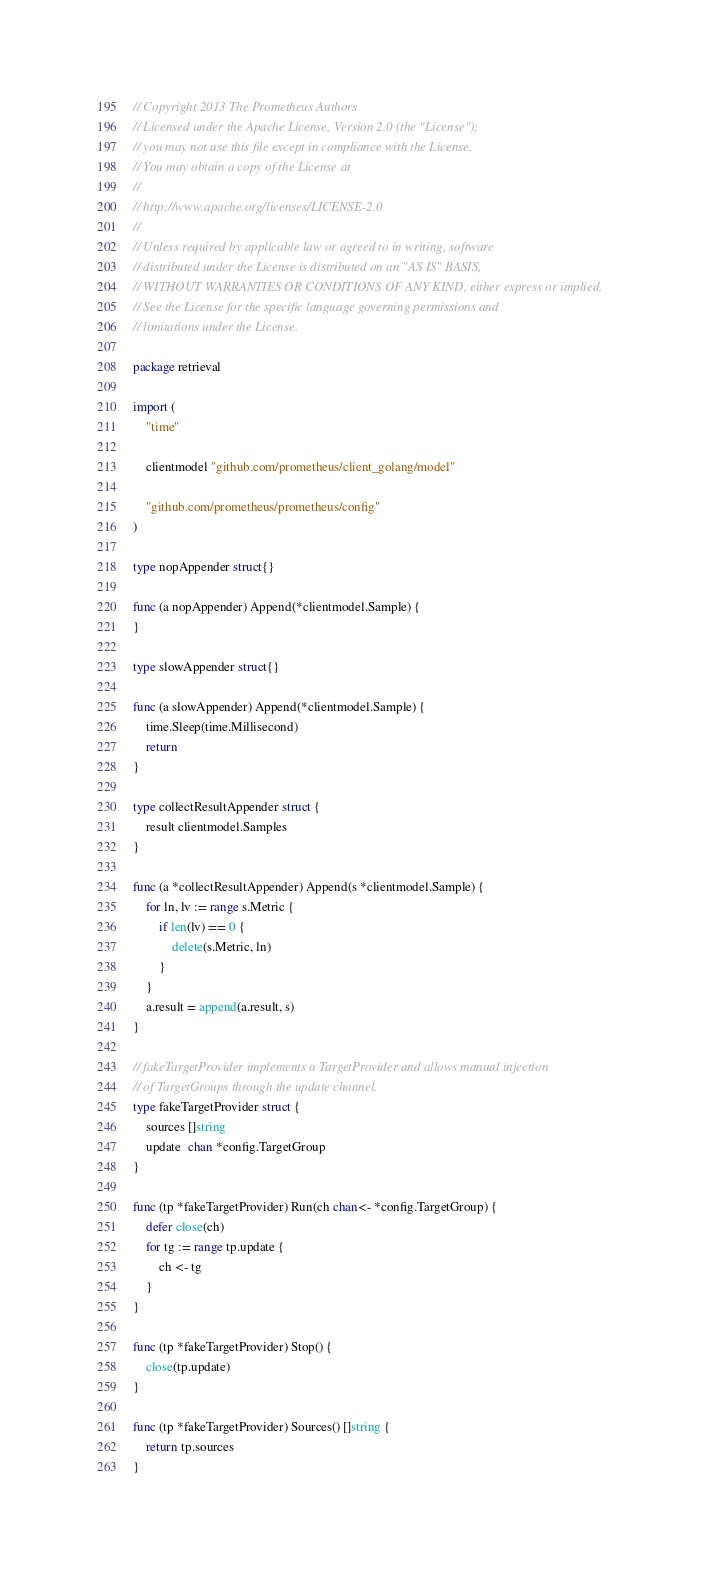Convert code to text. <code><loc_0><loc_0><loc_500><loc_500><_Go_>// Copyright 2013 The Prometheus Authors
// Licensed under the Apache License, Version 2.0 (the "License");
// you may not use this file except in compliance with the License.
// You may obtain a copy of the License at
//
// http://www.apache.org/licenses/LICENSE-2.0
//
// Unless required by applicable law or agreed to in writing, software
// distributed under the License is distributed on an "AS IS" BASIS,
// WITHOUT WARRANTIES OR CONDITIONS OF ANY KIND, either express or implied.
// See the License for the specific language governing permissions and
// limitations under the License.

package retrieval

import (
	"time"

	clientmodel "github.com/prometheus/client_golang/model"

	"github.com/prometheus/prometheus/config"
)

type nopAppender struct{}

func (a nopAppender) Append(*clientmodel.Sample) {
}

type slowAppender struct{}

func (a slowAppender) Append(*clientmodel.Sample) {
	time.Sleep(time.Millisecond)
	return
}

type collectResultAppender struct {
	result clientmodel.Samples
}

func (a *collectResultAppender) Append(s *clientmodel.Sample) {
	for ln, lv := range s.Metric {
		if len(lv) == 0 {
			delete(s.Metric, ln)
		}
	}
	a.result = append(a.result, s)
}

// fakeTargetProvider implements a TargetProvider and allows manual injection
// of TargetGroups through the update channel.
type fakeTargetProvider struct {
	sources []string
	update  chan *config.TargetGroup
}

func (tp *fakeTargetProvider) Run(ch chan<- *config.TargetGroup) {
	defer close(ch)
	for tg := range tp.update {
		ch <- tg
	}
}

func (tp *fakeTargetProvider) Stop() {
	close(tp.update)
}

func (tp *fakeTargetProvider) Sources() []string {
	return tp.sources
}
</code> 